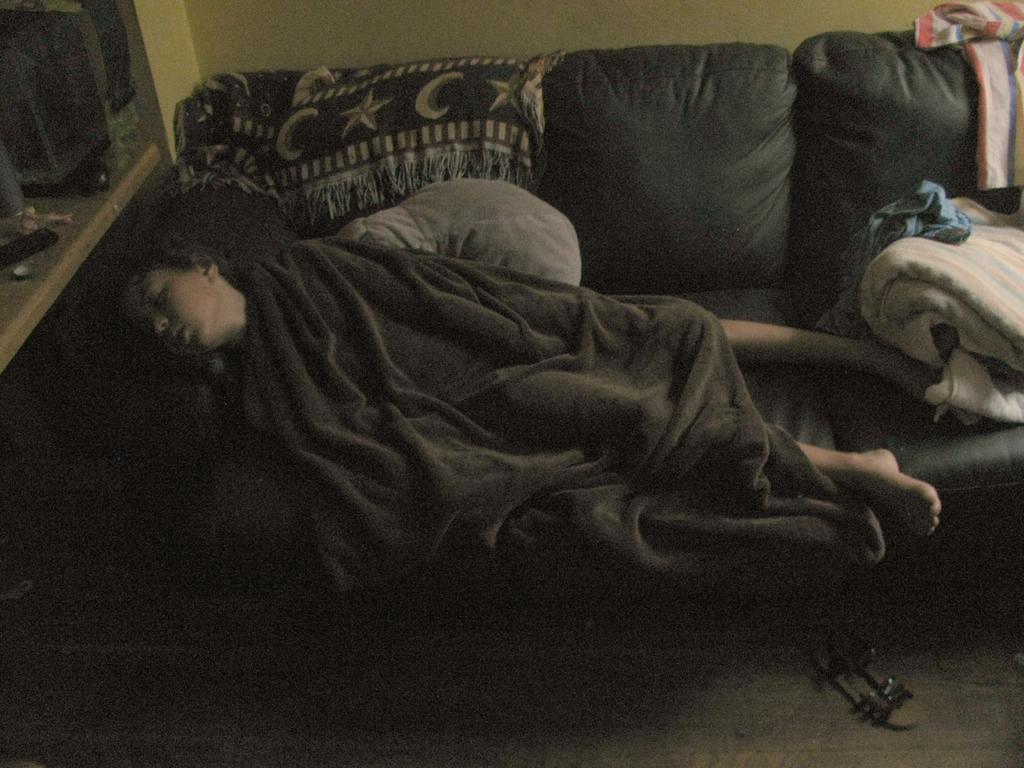Please provide a concise description of this image. Here is a boy sleeping on the couch. He is covered with blanket. I can see another blanket and some clothes placed on the couch. This couch is of black in color. And here I can see some objects placed. 